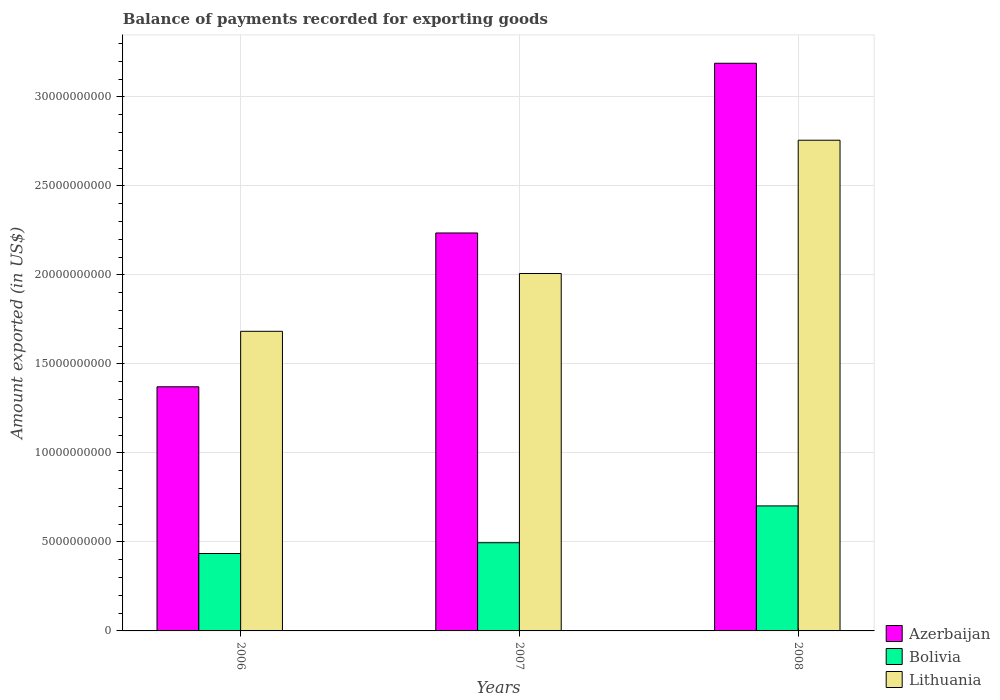How many different coloured bars are there?
Give a very brief answer. 3. How many groups of bars are there?
Give a very brief answer. 3. How many bars are there on the 2nd tick from the left?
Give a very brief answer. 3. How many bars are there on the 2nd tick from the right?
Your answer should be compact. 3. What is the label of the 1st group of bars from the left?
Give a very brief answer. 2006. In how many cases, is the number of bars for a given year not equal to the number of legend labels?
Keep it short and to the point. 0. What is the amount exported in Lithuania in 2006?
Your answer should be compact. 1.68e+1. Across all years, what is the maximum amount exported in Azerbaijan?
Ensure brevity in your answer.  3.19e+1. Across all years, what is the minimum amount exported in Azerbaijan?
Your answer should be compact. 1.37e+1. In which year was the amount exported in Bolivia maximum?
Give a very brief answer. 2008. What is the total amount exported in Lithuania in the graph?
Offer a terse response. 6.45e+1. What is the difference between the amount exported in Bolivia in 2006 and that in 2008?
Offer a terse response. -2.67e+09. What is the difference between the amount exported in Bolivia in 2008 and the amount exported in Azerbaijan in 2006?
Give a very brief answer. -6.69e+09. What is the average amount exported in Lithuania per year?
Keep it short and to the point. 2.15e+1. In the year 2007, what is the difference between the amount exported in Azerbaijan and amount exported in Bolivia?
Offer a very short reply. 1.74e+1. In how many years, is the amount exported in Bolivia greater than 8000000000 US$?
Your response must be concise. 0. What is the ratio of the amount exported in Bolivia in 2006 to that in 2008?
Your response must be concise. 0.62. Is the difference between the amount exported in Azerbaijan in 2007 and 2008 greater than the difference between the amount exported in Bolivia in 2007 and 2008?
Give a very brief answer. No. What is the difference between the highest and the second highest amount exported in Azerbaijan?
Your answer should be very brief. 9.53e+09. What is the difference between the highest and the lowest amount exported in Bolivia?
Ensure brevity in your answer.  2.67e+09. Is the sum of the amount exported in Azerbaijan in 2007 and 2008 greater than the maximum amount exported in Lithuania across all years?
Provide a succinct answer. Yes. What does the 1st bar from the right in 2007 represents?
Your response must be concise. Lithuania. How many bars are there?
Provide a short and direct response. 9. What is the difference between two consecutive major ticks on the Y-axis?
Keep it short and to the point. 5.00e+09. Are the values on the major ticks of Y-axis written in scientific E-notation?
Give a very brief answer. No. Does the graph contain grids?
Your answer should be very brief. Yes. How many legend labels are there?
Provide a succinct answer. 3. How are the legend labels stacked?
Keep it short and to the point. Vertical. What is the title of the graph?
Your response must be concise. Balance of payments recorded for exporting goods. Does "Caribbean small states" appear as one of the legend labels in the graph?
Your answer should be compact. No. What is the label or title of the X-axis?
Offer a terse response. Years. What is the label or title of the Y-axis?
Offer a very short reply. Amount exported (in US$). What is the Amount exported (in US$) of Azerbaijan in 2006?
Offer a very short reply. 1.37e+1. What is the Amount exported (in US$) in Bolivia in 2006?
Offer a terse response. 4.35e+09. What is the Amount exported (in US$) in Lithuania in 2006?
Your answer should be compact. 1.68e+1. What is the Amount exported (in US$) in Azerbaijan in 2007?
Provide a succinct answer. 2.24e+1. What is the Amount exported (in US$) in Bolivia in 2007?
Keep it short and to the point. 4.95e+09. What is the Amount exported (in US$) in Lithuania in 2007?
Your answer should be very brief. 2.01e+1. What is the Amount exported (in US$) of Azerbaijan in 2008?
Ensure brevity in your answer.  3.19e+1. What is the Amount exported (in US$) of Bolivia in 2008?
Offer a terse response. 7.02e+09. What is the Amount exported (in US$) in Lithuania in 2008?
Offer a very short reply. 2.76e+1. Across all years, what is the maximum Amount exported (in US$) of Azerbaijan?
Your answer should be very brief. 3.19e+1. Across all years, what is the maximum Amount exported (in US$) of Bolivia?
Offer a terse response. 7.02e+09. Across all years, what is the maximum Amount exported (in US$) in Lithuania?
Provide a short and direct response. 2.76e+1. Across all years, what is the minimum Amount exported (in US$) of Azerbaijan?
Your answer should be very brief. 1.37e+1. Across all years, what is the minimum Amount exported (in US$) in Bolivia?
Your answer should be very brief. 4.35e+09. Across all years, what is the minimum Amount exported (in US$) of Lithuania?
Offer a very short reply. 1.68e+1. What is the total Amount exported (in US$) in Azerbaijan in the graph?
Offer a very short reply. 6.80e+1. What is the total Amount exported (in US$) of Bolivia in the graph?
Make the answer very short. 1.63e+1. What is the total Amount exported (in US$) of Lithuania in the graph?
Your response must be concise. 6.45e+1. What is the difference between the Amount exported (in US$) in Azerbaijan in 2006 and that in 2007?
Give a very brief answer. -8.64e+09. What is the difference between the Amount exported (in US$) in Bolivia in 2006 and that in 2007?
Give a very brief answer. -6.05e+08. What is the difference between the Amount exported (in US$) in Lithuania in 2006 and that in 2007?
Make the answer very short. -3.25e+09. What is the difference between the Amount exported (in US$) in Azerbaijan in 2006 and that in 2008?
Offer a terse response. -1.82e+1. What is the difference between the Amount exported (in US$) in Bolivia in 2006 and that in 2008?
Give a very brief answer. -2.67e+09. What is the difference between the Amount exported (in US$) of Lithuania in 2006 and that in 2008?
Provide a short and direct response. -1.07e+1. What is the difference between the Amount exported (in US$) of Azerbaijan in 2007 and that in 2008?
Keep it short and to the point. -9.53e+09. What is the difference between the Amount exported (in US$) in Bolivia in 2007 and that in 2008?
Keep it short and to the point. -2.07e+09. What is the difference between the Amount exported (in US$) in Lithuania in 2007 and that in 2008?
Keep it short and to the point. -7.49e+09. What is the difference between the Amount exported (in US$) of Azerbaijan in 2006 and the Amount exported (in US$) of Bolivia in 2007?
Make the answer very short. 8.76e+09. What is the difference between the Amount exported (in US$) of Azerbaijan in 2006 and the Amount exported (in US$) of Lithuania in 2007?
Give a very brief answer. -6.36e+09. What is the difference between the Amount exported (in US$) of Bolivia in 2006 and the Amount exported (in US$) of Lithuania in 2007?
Keep it short and to the point. -1.57e+1. What is the difference between the Amount exported (in US$) of Azerbaijan in 2006 and the Amount exported (in US$) of Bolivia in 2008?
Your answer should be compact. 6.69e+09. What is the difference between the Amount exported (in US$) in Azerbaijan in 2006 and the Amount exported (in US$) in Lithuania in 2008?
Provide a succinct answer. -1.39e+1. What is the difference between the Amount exported (in US$) of Bolivia in 2006 and the Amount exported (in US$) of Lithuania in 2008?
Provide a succinct answer. -2.32e+1. What is the difference between the Amount exported (in US$) in Azerbaijan in 2007 and the Amount exported (in US$) in Bolivia in 2008?
Offer a terse response. 1.53e+1. What is the difference between the Amount exported (in US$) of Azerbaijan in 2007 and the Amount exported (in US$) of Lithuania in 2008?
Offer a very short reply. -5.21e+09. What is the difference between the Amount exported (in US$) in Bolivia in 2007 and the Amount exported (in US$) in Lithuania in 2008?
Your answer should be very brief. -2.26e+1. What is the average Amount exported (in US$) in Azerbaijan per year?
Provide a succinct answer. 2.27e+1. What is the average Amount exported (in US$) of Bolivia per year?
Provide a short and direct response. 5.44e+09. What is the average Amount exported (in US$) of Lithuania per year?
Your answer should be very brief. 2.15e+1. In the year 2006, what is the difference between the Amount exported (in US$) in Azerbaijan and Amount exported (in US$) in Bolivia?
Give a very brief answer. 9.37e+09. In the year 2006, what is the difference between the Amount exported (in US$) of Azerbaijan and Amount exported (in US$) of Lithuania?
Give a very brief answer. -3.12e+09. In the year 2006, what is the difference between the Amount exported (in US$) in Bolivia and Amount exported (in US$) in Lithuania?
Offer a very short reply. -1.25e+1. In the year 2007, what is the difference between the Amount exported (in US$) in Azerbaijan and Amount exported (in US$) in Bolivia?
Offer a terse response. 1.74e+1. In the year 2007, what is the difference between the Amount exported (in US$) in Azerbaijan and Amount exported (in US$) in Lithuania?
Make the answer very short. 2.28e+09. In the year 2007, what is the difference between the Amount exported (in US$) of Bolivia and Amount exported (in US$) of Lithuania?
Your answer should be very brief. -1.51e+1. In the year 2008, what is the difference between the Amount exported (in US$) of Azerbaijan and Amount exported (in US$) of Bolivia?
Provide a short and direct response. 2.49e+1. In the year 2008, what is the difference between the Amount exported (in US$) in Azerbaijan and Amount exported (in US$) in Lithuania?
Provide a short and direct response. 4.32e+09. In the year 2008, what is the difference between the Amount exported (in US$) in Bolivia and Amount exported (in US$) in Lithuania?
Make the answer very short. -2.05e+1. What is the ratio of the Amount exported (in US$) of Azerbaijan in 2006 to that in 2007?
Your response must be concise. 0.61. What is the ratio of the Amount exported (in US$) in Bolivia in 2006 to that in 2007?
Your answer should be compact. 0.88. What is the ratio of the Amount exported (in US$) in Lithuania in 2006 to that in 2007?
Give a very brief answer. 0.84. What is the ratio of the Amount exported (in US$) of Azerbaijan in 2006 to that in 2008?
Your answer should be very brief. 0.43. What is the ratio of the Amount exported (in US$) of Bolivia in 2006 to that in 2008?
Provide a short and direct response. 0.62. What is the ratio of the Amount exported (in US$) in Lithuania in 2006 to that in 2008?
Ensure brevity in your answer.  0.61. What is the ratio of the Amount exported (in US$) of Azerbaijan in 2007 to that in 2008?
Give a very brief answer. 0.7. What is the ratio of the Amount exported (in US$) in Bolivia in 2007 to that in 2008?
Provide a short and direct response. 0.71. What is the ratio of the Amount exported (in US$) in Lithuania in 2007 to that in 2008?
Your answer should be compact. 0.73. What is the difference between the highest and the second highest Amount exported (in US$) of Azerbaijan?
Provide a succinct answer. 9.53e+09. What is the difference between the highest and the second highest Amount exported (in US$) of Bolivia?
Your response must be concise. 2.07e+09. What is the difference between the highest and the second highest Amount exported (in US$) in Lithuania?
Give a very brief answer. 7.49e+09. What is the difference between the highest and the lowest Amount exported (in US$) in Azerbaijan?
Provide a succinct answer. 1.82e+1. What is the difference between the highest and the lowest Amount exported (in US$) in Bolivia?
Your answer should be very brief. 2.67e+09. What is the difference between the highest and the lowest Amount exported (in US$) of Lithuania?
Provide a succinct answer. 1.07e+1. 